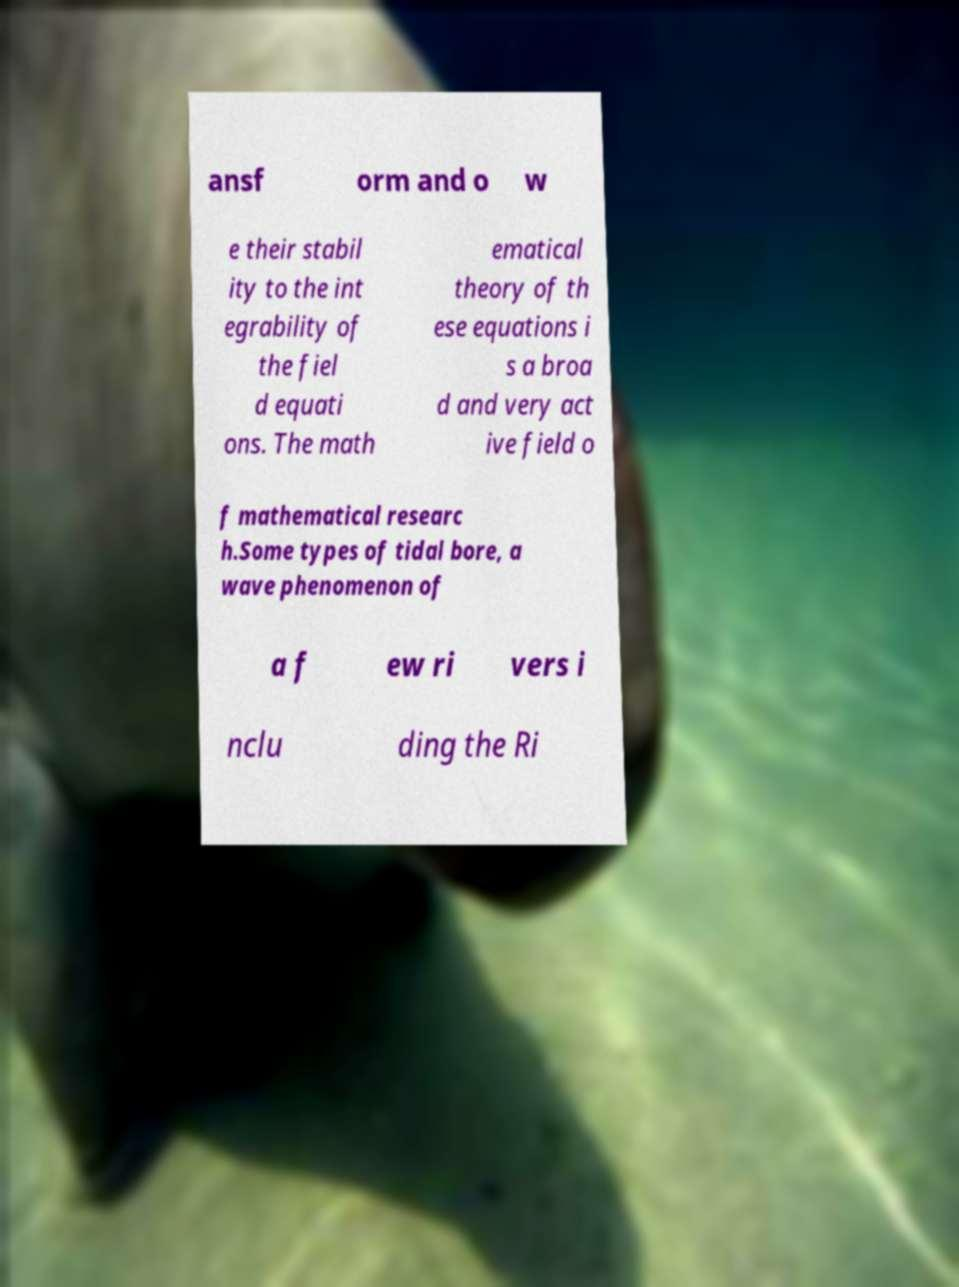I need the written content from this picture converted into text. Can you do that? ansf orm and o w e their stabil ity to the int egrability of the fiel d equati ons. The math ematical theory of th ese equations i s a broa d and very act ive field o f mathematical researc h.Some types of tidal bore, a wave phenomenon of a f ew ri vers i nclu ding the Ri 